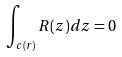<formula> <loc_0><loc_0><loc_500><loc_500>\int _ { c ( r ) } R ( z ) d z = 0</formula> 